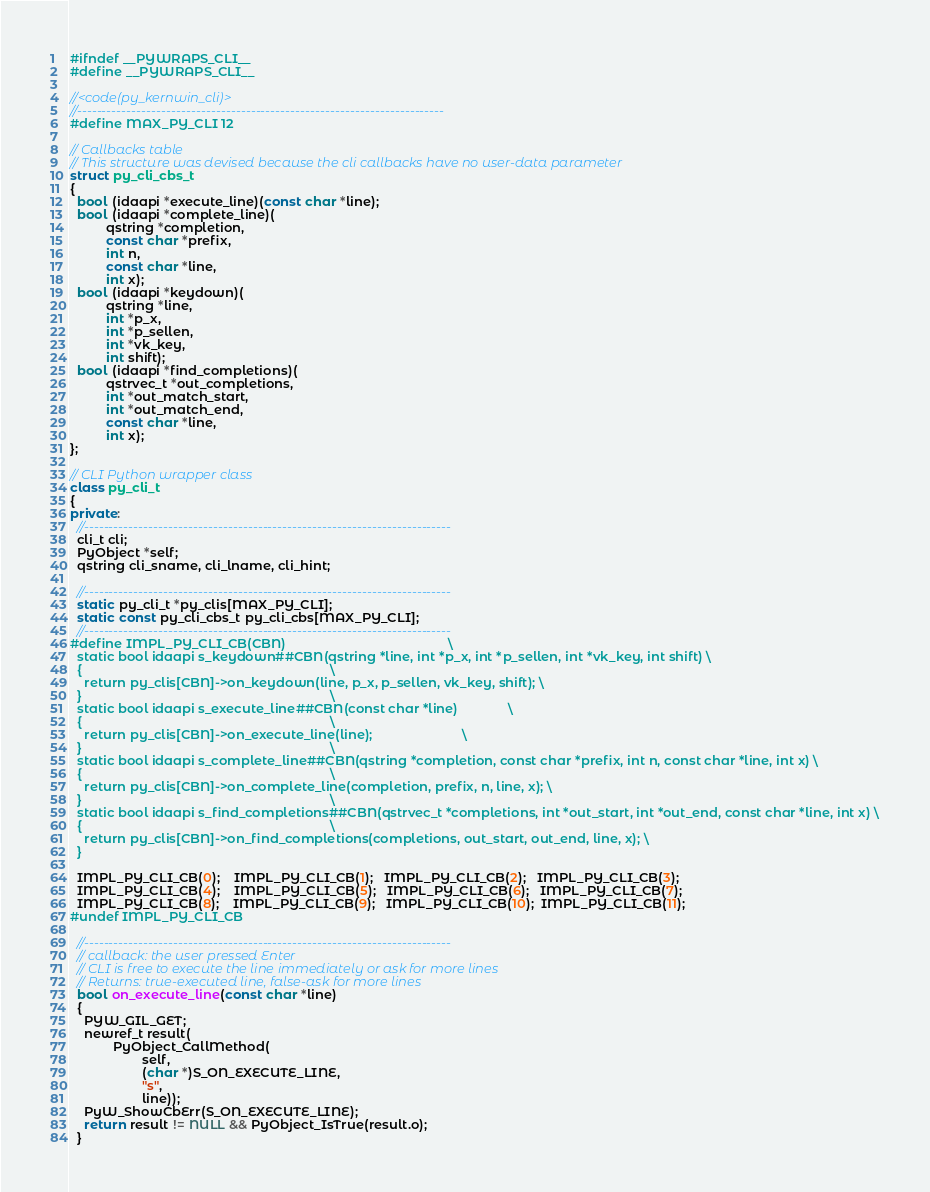<code> <loc_0><loc_0><loc_500><loc_500><_C++_>#ifndef __PYWRAPS_CLI__
#define __PYWRAPS_CLI__

//<code(py_kernwin_cli)>
//--------------------------------------------------------------------------
#define MAX_PY_CLI 12

// Callbacks table
// This structure was devised because the cli callbacks have no user-data parameter
struct py_cli_cbs_t
{
  bool (idaapi *execute_line)(const char *line);
  bool (idaapi *complete_line)(
          qstring *completion,
          const char *prefix,
          int n,
          const char *line,
          int x);
  bool (idaapi *keydown)(
          qstring *line,
          int *p_x,
          int *p_sellen,
          int *vk_key,
          int shift);
  bool (idaapi *find_completions)(
          qstrvec_t *out_completions,
          int *out_match_start,
          int *out_match_end,
          const char *line,
          int x);
};

// CLI Python wrapper class
class py_cli_t
{
private:
  //--------------------------------------------------------------------------
  cli_t cli;
  PyObject *self;
  qstring cli_sname, cli_lname, cli_hint;

  //--------------------------------------------------------------------------
  static py_cli_t *py_clis[MAX_PY_CLI];
  static const py_cli_cbs_t py_cli_cbs[MAX_PY_CLI];
  //--------------------------------------------------------------------------
#define IMPL_PY_CLI_CB(CBN)                                             \
  static bool idaapi s_keydown##CBN(qstring *line, int *p_x, int *p_sellen, int *vk_key, int shift) \
  {                                                                     \
    return py_clis[CBN]->on_keydown(line, p_x, p_sellen, vk_key, shift); \
  }                                                                     \
  static bool idaapi s_execute_line##CBN(const char *line)              \
  {                                                                     \
    return py_clis[CBN]->on_execute_line(line);                         \
  }                                                                     \
  static bool idaapi s_complete_line##CBN(qstring *completion, const char *prefix, int n, const char *line, int x) \
  {                                                                     \
    return py_clis[CBN]->on_complete_line(completion, prefix, n, line, x); \
  }                                                                     \
  static bool idaapi s_find_completions##CBN(qstrvec_t *completions, int *out_start, int *out_end, const char *line, int x) \
  {                                                                     \
    return py_clis[CBN]->on_find_completions(completions, out_start, out_end, line, x); \
  }

  IMPL_PY_CLI_CB(0);    IMPL_PY_CLI_CB(1);   IMPL_PY_CLI_CB(2);   IMPL_PY_CLI_CB(3);
  IMPL_PY_CLI_CB(4);    IMPL_PY_CLI_CB(5);   IMPL_PY_CLI_CB(6);   IMPL_PY_CLI_CB(7);
  IMPL_PY_CLI_CB(8);    IMPL_PY_CLI_CB(9);   IMPL_PY_CLI_CB(10);  IMPL_PY_CLI_CB(11);
#undef IMPL_PY_CLI_CB

  //--------------------------------------------------------------------------
  // callback: the user pressed Enter
  // CLI is free to execute the line immediately or ask for more lines
  // Returns: true-executed line, false-ask for more lines
  bool on_execute_line(const char *line)
  {
    PYW_GIL_GET;
    newref_t result(
            PyObject_CallMethod(
                    self,
                    (char *)S_ON_EXECUTE_LINE,
                    "s",
                    line));
    PyW_ShowCbErr(S_ON_EXECUTE_LINE);
    return result != NULL && PyObject_IsTrue(result.o);
  }
</code> 